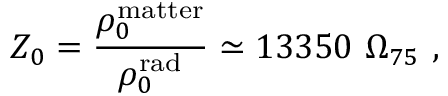Convert formula to latex. <formula><loc_0><loc_0><loc_500><loc_500>Z _ { 0 } = { \frac { \rho _ { 0 } ^ { m a t t e r } } { \rho _ { 0 } ^ { r a d } } } \simeq 1 3 3 5 0 \ \Omega _ { 7 5 } \ ,</formula> 